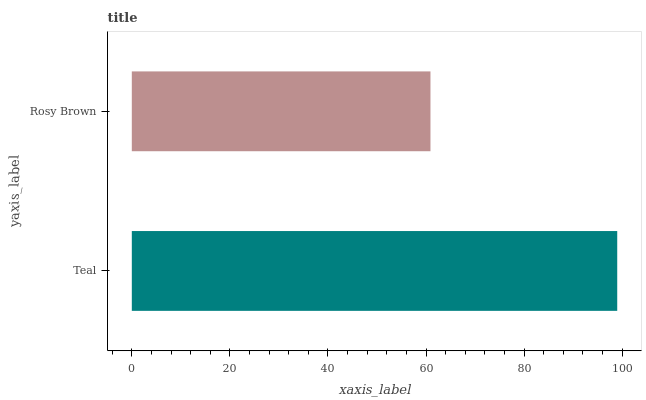Is Rosy Brown the minimum?
Answer yes or no. Yes. Is Teal the maximum?
Answer yes or no. Yes. Is Rosy Brown the maximum?
Answer yes or no. No. Is Teal greater than Rosy Brown?
Answer yes or no. Yes. Is Rosy Brown less than Teal?
Answer yes or no. Yes. Is Rosy Brown greater than Teal?
Answer yes or no. No. Is Teal less than Rosy Brown?
Answer yes or no. No. Is Teal the high median?
Answer yes or no. Yes. Is Rosy Brown the low median?
Answer yes or no. Yes. Is Rosy Brown the high median?
Answer yes or no. No. Is Teal the low median?
Answer yes or no. No. 